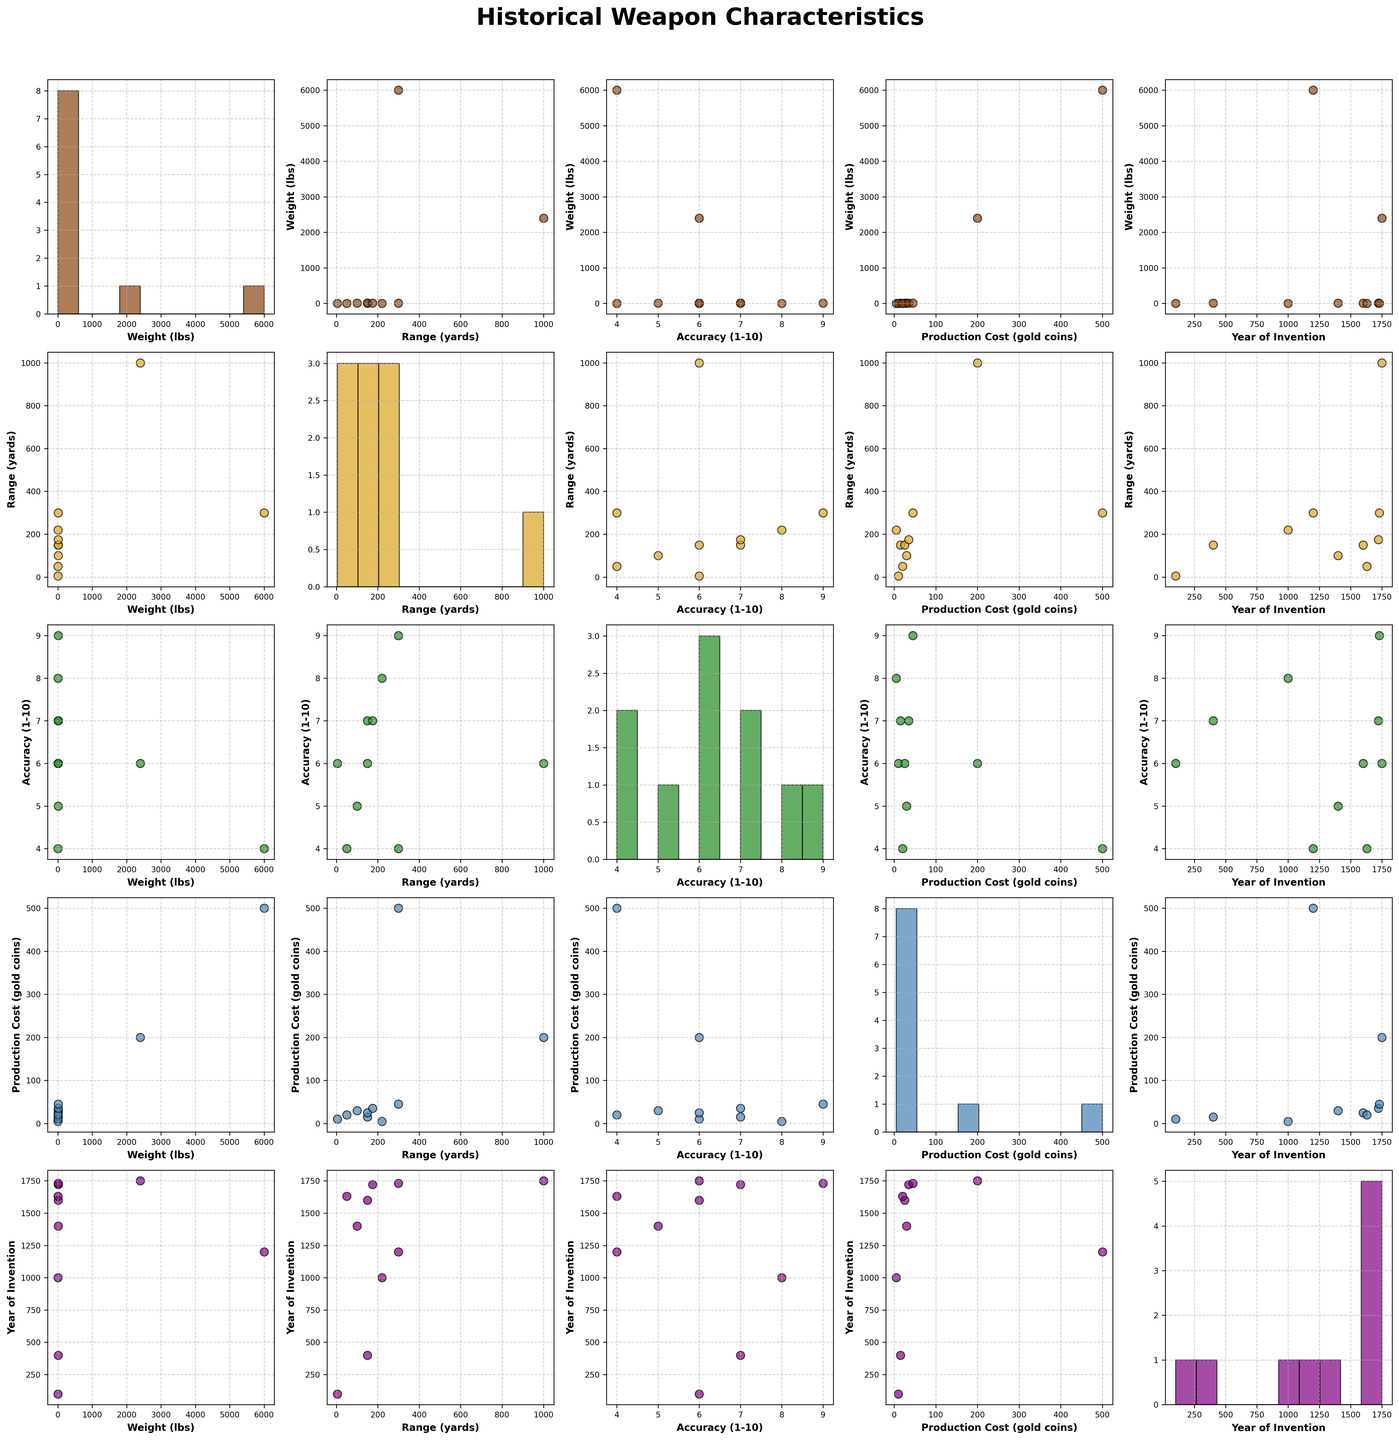what are the title and subtitle of the figure? The title is shown at the top of the scatterplot matrix, and the subtitle might be right below the main title. You can read them directly.
Answer: Historical Weapon Characteristics how many variables are presented in the scatterplot matrix? You can count the unique labels on either the rows or columns of the scatterplot matrix to determine the number of variables.
Answer: 5 what are the colors used in the scatterplot matrix, and do they repeat? By looking at the scatterplot matrix, you can identify the distinct colors used for different plots. Each color represents a unique variable's scatter or histograms.
Answer: 5 colors what is the relationship between the 'Range (yards)' and 'Accuracy (1-10)'? Locate the intersection of 'Range (yards)' and 'Accuracy (1-10)' and observe the scatter plot. You can see if there is a positive or negative trend, or if the points are scattered randomly.
Answer: Positive trend which weapon has the highest weight, and what is its range? Find the scatter plot where 'Weight (lbs)' and 'Range (yards)' intersect. Identify the data point that represents the highest weight and note its corresponding range.
Answer: Trebuchet, 300 yards which year had the highest production cost, and what was the cost? In the scatter plot where 'Year of Invention' intersects with 'Production Cost (gold coins)', find the data point with the highest production cost and note the corresponding year.
Answer: 1200, 500 gold coins how do the weights of the 'Arquebus' and 'Musket' compare? Find the data points for 'Arquebus' and 'Musket' in the 'Weight (lbs)' scatter plot or histogram and compare their values.
Answer: Musket is heavier which pair of variables has the most scattered data? Analyze the scatter plots in the matrix and identify the pair where the data points are least clustered and appear the most spread out.
Answer: 'Weight (lbs)' and 'Year of Invention' 